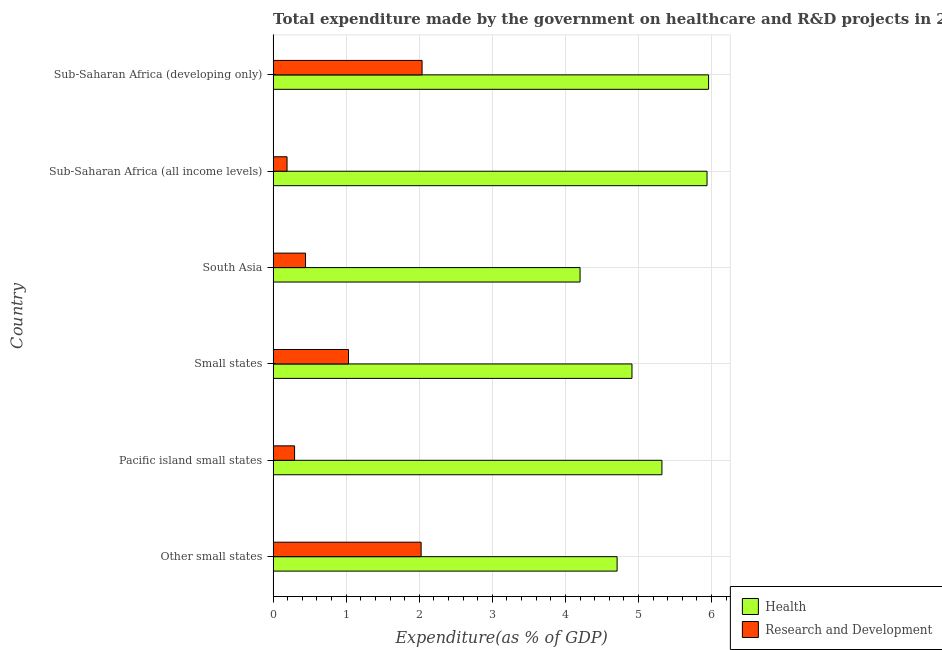How many groups of bars are there?
Provide a short and direct response. 6. Are the number of bars per tick equal to the number of legend labels?
Your answer should be very brief. Yes. Are the number of bars on each tick of the Y-axis equal?
Provide a short and direct response. Yes. What is the label of the 5th group of bars from the top?
Your response must be concise. Pacific island small states. In how many cases, is the number of bars for a given country not equal to the number of legend labels?
Provide a short and direct response. 0. What is the expenditure in healthcare in Sub-Saharan Africa (all income levels)?
Your answer should be very brief. 5.94. Across all countries, what is the maximum expenditure in healthcare?
Your response must be concise. 5.96. Across all countries, what is the minimum expenditure in healthcare?
Provide a short and direct response. 4.2. In which country was the expenditure in r&d maximum?
Your answer should be compact. Sub-Saharan Africa (developing only). In which country was the expenditure in r&d minimum?
Provide a short and direct response. Sub-Saharan Africa (all income levels). What is the total expenditure in healthcare in the graph?
Your response must be concise. 31.04. What is the difference between the expenditure in healthcare in Pacific island small states and that in Small states?
Your response must be concise. 0.41. What is the difference between the expenditure in r&d in Pacific island small states and the expenditure in healthcare in Small states?
Give a very brief answer. -4.62. What is the average expenditure in healthcare per country?
Keep it short and to the point. 5.17. What is the difference between the expenditure in r&d and expenditure in healthcare in Sub-Saharan Africa (developing only)?
Provide a short and direct response. -3.92. What is the ratio of the expenditure in healthcare in South Asia to that in Sub-Saharan Africa (all income levels)?
Your answer should be compact. 0.71. Is the difference between the expenditure in r&d in Pacific island small states and South Asia greater than the difference between the expenditure in healthcare in Pacific island small states and South Asia?
Give a very brief answer. No. What is the difference between the highest and the second highest expenditure in r&d?
Give a very brief answer. 0.01. What is the difference between the highest and the lowest expenditure in r&d?
Your answer should be very brief. 1.85. Is the sum of the expenditure in r&d in Pacific island small states and South Asia greater than the maximum expenditure in healthcare across all countries?
Provide a succinct answer. No. What does the 1st bar from the top in Other small states represents?
Offer a terse response. Research and Development. What does the 1st bar from the bottom in Pacific island small states represents?
Your answer should be compact. Health. How many bars are there?
Provide a short and direct response. 12. How many countries are there in the graph?
Your response must be concise. 6. Are the values on the major ticks of X-axis written in scientific E-notation?
Provide a short and direct response. No. What is the title of the graph?
Ensure brevity in your answer.  Total expenditure made by the government on healthcare and R&D projects in 2001. What is the label or title of the X-axis?
Offer a very short reply. Expenditure(as % of GDP). What is the label or title of the Y-axis?
Offer a very short reply. Country. What is the Expenditure(as % of GDP) in Health in Other small states?
Keep it short and to the point. 4.71. What is the Expenditure(as % of GDP) in Research and Development in Other small states?
Give a very brief answer. 2.03. What is the Expenditure(as % of GDP) in Health in Pacific island small states?
Ensure brevity in your answer.  5.32. What is the Expenditure(as % of GDP) in Research and Development in Pacific island small states?
Offer a very short reply. 0.29. What is the Expenditure(as % of GDP) in Health in Small states?
Offer a terse response. 4.91. What is the Expenditure(as % of GDP) in Research and Development in Small states?
Offer a very short reply. 1.03. What is the Expenditure(as % of GDP) of Health in South Asia?
Keep it short and to the point. 4.2. What is the Expenditure(as % of GDP) in Research and Development in South Asia?
Ensure brevity in your answer.  0.44. What is the Expenditure(as % of GDP) of Health in Sub-Saharan Africa (all income levels)?
Your answer should be compact. 5.94. What is the Expenditure(as % of GDP) in Research and Development in Sub-Saharan Africa (all income levels)?
Provide a succinct answer. 0.19. What is the Expenditure(as % of GDP) in Health in Sub-Saharan Africa (developing only)?
Your response must be concise. 5.96. What is the Expenditure(as % of GDP) of Research and Development in Sub-Saharan Africa (developing only)?
Your answer should be very brief. 2.04. Across all countries, what is the maximum Expenditure(as % of GDP) in Health?
Keep it short and to the point. 5.96. Across all countries, what is the maximum Expenditure(as % of GDP) of Research and Development?
Provide a short and direct response. 2.04. Across all countries, what is the minimum Expenditure(as % of GDP) in Health?
Your answer should be very brief. 4.2. Across all countries, what is the minimum Expenditure(as % of GDP) of Research and Development?
Offer a very short reply. 0.19. What is the total Expenditure(as % of GDP) in Health in the graph?
Your answer should be compact. 31.04. What is the total Expenditure(as % of GDP) of Research and Development in the graph?
Your answer should be compact. 6.02. What is the difference between the Expenditure(as % of GDP) of Health in Other small states and that in Pacific island small states?
Your answer should be very brief. -0.61. What is the difference between the Expenditure(as % of GDP) in Research and Development in Other small states and that in Pacific island small states?
Your answer should be compact. 1.73. What is the difference between the Expenditure(as % of GDP) of Health in Other small states and that in Small states?
Your answer should be very brief. -0.2. What is the difference between the Expenditure(as % of GDP) of Research and Development in Other small states and that in Small states?
Your answer should be very brief. 0.99. What is the difference between the Expenditure(as % of GDP) of Health in Other small states and that in South Asia?
Keep it short and to the point. 0.51. What is the difference between the Expenditure(as % of GDP) in Research and Development in Other small states and that in South Asia?
Keep it short and to the point. 1.58. What is the difference between the Expenditure(as % of GDP) of Health in Other small states and that in Sub-Saharan Africa (all income levels)?
Your response must be concise. -1.23. What is the difference between the Expenditure(as % of GDP) of Research and Development in Other small states and that in Sub-Saharan Africa (all income levels)?
Make the answer very short. 1.83. What is the difference between the Expenditure(as % of GDP) in Health in Other small states and that in Sub-Saharan Africa (developing only)?
Your answer should be very brief. -1.25. What is the difference between the Expenditure(as % of GDP) in Research and Development in Other small states and that in Sub-Saharan Africa (developing only)?
Offer a terse response. -0.01. What is the difference between the Expenditure(as % of GDP) of Health in Pacific island small states and that in Small states?
Your answer should be very brief. 0.41. What is the difference between the Expenditure(as % of GDP) of Research and Development in Pacific island small states and that in Small states?
Provide a succinct answer. -0.74. What is the difference between the Expenditure(as % of GDP) of Health in Pacific island small states and that in South Asia?
Offer a very short reply. 1.12. What is the difference between the Expenditure(as % of GDP) in Research and Development in Pacific island small states and that in South Asia?
Make the answer very short. -0.15. What is the difference between the Expenditure(as % of GDP) in Health in Pacific island small states and that in Sub-Saharan Africa (all income levels)?
Keep it short and to the point. -0.62. What is the difference between the Expenditure(as % of GDP) in Research and Development in Pacific island small states and that in Sub-Saharan Africa (all income levels)?
Offer a very short reply. 0.1. What is the difference between the Expenditure(as % of GDP) in Health in Pacific island small states and that in Sub-Saharan Africa (developing only)?
Make the answer very short. -0.64. What is the difference between the Expenditure(as % of GDP) of Research and Development in Pacific island small states and that in Sub-Saharan Africa (developing only)?
Your answer should be very brief. -1.74. What is the difference between the Expenditure(as % of GDP) of Health in Small states and that in South Asia?
Your answer should be compact. 0.71. What is the difference between the Expenditure(as % of GDP) of Research and Development in Small states and that in South Asia?
Offer a very short reply. 0.59. What is the difference between the Expenditure(as % of GDP) of Health in Small states and that in Sub-Saharan Africa (all income levels)?
Make the answer very short. -1.03. What is the difference between the Expenditure(as % of GDP) of Research and Development in Small states and that in Sub-Saharan Africa (all income levels)?
Your response must be concise. 0.84. What is the difference between the Expenditure(as % of GDP) of Health in Small states and that in Sub-Saharan Africa (developing only)?
Your answer should be compact. -1.05. What is the difference between the Expenditure(as % of GDP) in Research and Development in Small states and that in Sub-Saharan Africa (developing only)?
Make the answer very short. -1.01. What is the difference between the Expenditure(as % of GDP) of Health in South Asia and that in Sub-Saharan Africa (all income levels)?
Keep it short and to the point. -1.74. What is the difference between the Expenditure(as % of GDP) in Research and Development in South Asia and that in Sub-Saharan Africa (all income levels)?
Keep it short and to the point. 0.25. What is the difference between the Expenditure(as % of GDP) of Health in South Asia and that in Sub-Saharan Africa (developing only)?
Keep it short and to the point. -1.76. What is the difference between the Expenditure(as % of GDP) in Research and Development in South Asia and that in Sub-Saharan Africa (developing only)?
Your response must be concise. -1.6. What is the difference between the Expenditure(as % of GDP) of Health in Sub-Saharan Africa (all income levels) and that in Sub-Saharan Africa (developing only)?
Make the answer very short. -0.02. What is the difference between the Expenditure(as % of GDP) of Research and Development in Sub-Saharan Africa (all income levels) and that in Sub-Saharan Africa (developing only)?
Your response must be concise. -1.85. What is the difference between the Expenditure(as % of GDP) of Health in Other small states and the Expenditure(as % of GDP) of Research and Development in Pacific island small states?
Your answer should be compact. 4.41. What is the difference between the Expenditure(as % of GDP) in Health in Other small states and the Expenditure(as % of GDP) in Research and Development in Small states?
Provide a short and direct response. 3.68. What is the difference between the Expenditure(as % of GDP) of Health in Other small states and the Expenditure(as % of GDP) of Research and Development in South Asia?
Your response must be concise. 4.26. What is the difference between the Expenditure(as % of GDP) in Health in Other small states and the Expenditure(as % of GDP) in Research and Development in Sub-Saharan Africa (all income levels)?
Give a very brief answer. 4.52. What is the difference between the Expenditure(as % of GDP) of Health in Other small states and the Expenditure(as % of GDP) of Research and Development in Sub-Saharan Africa (developing only)?
Offer a terse response. 2.67. What is the difference between the Expenditure(as % of GDP) of Health in Pacific island small states and the Expenditure(as % of GDP) of Research and Development in Small states?
Give a very brief answer. 4.29. What is the difference between the Expenditure(as % of GDP) in Health in Pacific island small states and the Expenditure(as % of GDP) in Research and Development in South Asia?
Offer a terse response. 4.88. What is the difference between the Expenditure(as % of GDP) in Health in Pacific island small states and the Expenditure(as % of GDP) in Research and Development in Sub-Saharan Africa (all income levels)?
Your response must be concise. 5.13. What is the difference between the Expenditure(as % of GDP) in Health in Pacific island small states and the Expenditure(as % of GDP) in Research and Development in Sub-Saharan Africa (developing only)?
Your answer should be very brief. 3.28. What is the difference between the Expenditure(as % of GDP) of Health in Small states and the Expenditure(as % of GDP) of Research and Development in South Asia?
Your answer should be very brief. 4.47. What is the difference between the Expenditure(as % of GDP) of Health in Small states and the Expenditure(as % of GDP) of Research and Development in Sub-Saharan Africa (all income levels)?
Your answer should be very brief. 4.72. What is the difference between the Expenditure(as % of GDP) of Health in Small states and the Expenditure(as % of GDP) of Research and Development in Sub-Saharan Africa (developing only)?
Ensure brevity in your answer.  2.87. What is the difference between the Expenditure(as % of GDP) in Health in South Asia and the Expenditure(as % of GDP) in Research and Development in Sub-Saharan Africa (all income levels)?
Give a very brief answer. 4.01. What is the difference between the Expenditure(as % of GDP) of Health in South Asia and the Expenditure(as % of GDP) of Research and Development in Sub-Saharan Africa (developing only)?
Your answer should be compact. 2.16. What is the difference between the Expenditure(as % of GDP) in Health in Sub-Saharan Africa (all income levels) and the Expenditure(as % of GDP) in Research and Development in Sub-Saharan Africa (developing only)?
Your answer should be compact. 3.9. What is the average Expenditure(as % of GDP) in Health per country?
Give a very brief answer. 5.17. What is the average Expenditure(as % of GDP) in Research and Development per country?
Ensure brevity in your answer.  1. What is the difference between the Expenditure(as % of GDP) in Health and Expenditure(as % of GDP) in Research and Development in Other small states?
Provide a succinct answer. 2.68. What is the difference between the Expenditure(as % of GDP) of Health and Expenditure(as % of GDP) of Research and Development in Pacific island small states?
Keep it short and to the point. 5.03. What is the difference between the Expenditure(as % of GDP) in Health and Expenditure(as % of GDP) in Research and Development in Small states?
Offer a very short reply. 3.88. What is the difference between the Expenditure(as % of GDP) in Health and Expenditure(as % of GDP) in Research and Development in South Asia?
Your answer should be very brief. 3.76. What is the difference between the Expenditure(as % of GDP) in Health and Expenditure(as % of GDP) in Research and Development in Sub-Saharan Africa (all income levels)?
Ensure brevity in your answer.  5.75. What is the difference between the Expenditure(as % of GDP) of Health and Expenditure(as % of GDP) of Research and Development in Sub-Saharan Africa (developing only)?
Offer a very short reply. 3.92. What is the ratio of the Expenditure(as % of GDP) of Health in Other small states to that in Pacific island small states?
Your answer should be compact. 0.88. What is the ratio of the Expenditure(as % of GDP) of Research and Development in Other small states to that in Pacific island small states?
Your answer should be very brief. 6.9. What is the ratio of the Expenditure(as % of GDP) of Health in Other small states to that in Small states?
Ensure brevity in your answer.  0.96. What is the ratio of the Expenditure(as % of GDP) in Research and Development in Other small states to that in Small states?
Ensure brevity in your answer.  1.96. What is the ratio of the Expenditure(as % of GDP) of Health in Other small states to that in South Asia?
Provide a short and direct response. 1.12. What is the ratio of the Expenditure(as % of GDP) in Research and Development in Other small states to that in South Asia?
Provide a short and direct response. 4.57. What is the ratio of the Expenditure(as % of GDP) in Health in Other small states to that in Sub-Saharan Africa (all income levels)?
Keep it short and to the point. 0.79. What is the ratio of the Expenditure(as % of GDP) of Research and Development in Other small states to that in Sub-Saharan Africa (all income levels)?
Provide a succinct answer. 10.63. What is the ratio of the Expenditure(as % of GDP) in Health in Other small states to that in Sub-Saharan Africa (developing only)?
Offer a very short reply. 0.79. What is the ratio of the Expenditure(as % of GDP) in Research and Development in Other small states to that in Sub-Saharan Africa (developing only)?
Provide a short and direct response. 0.99. What is the ratio of the Expenditure(as % of GDP) in Health in Pacific island small states to that in Small states?
Make the answer very short. 1.08. What is the ratio of the Expenditure(as % of GDP) of Research and Development in Pacific island small states to that in Small states?
Give a very brief answer. 0.28. What is the ratio of the Expenditure(as % of GDP) in Health in Pacific island small states to that in South Asia?
Give a very brief answer. 1.27. What is the ratio of the Expenditure(as % of GDP) in Research and Development in Pacific island small states to that in South Asia?
Ensure brevity in your answer.  0.66. What is the ratio of the Expenditure(as % of GDP) in Health in Pacific island small states to that in Sub-Saharan Africa (all income levels)?
Provide a short and direct response. 0.9. What is the ratio of the Expenditure(as % of GDP) of Research and Development in Pacific island small states to that in Sub-Saharan Africa (all income levels)?
Give a very brief answer. 1.54. What is the ratio of the Expenditure(as % of GDP) of Health in Pacific island small states to that in Sub-Saharan Africa (developing only)?
Ensure brevity in your answer.  0.89. What is the ratio of the Expenditure(as % of GDP) in Research and Development in Pacific island small states to that in Sub-Saharan Africa (developing only)?
Ensure brevity in your answer.  0.14. What is the ratio of the Expenditure(as % of GDP) in Health in Small states to that in South Asia?
Make the answer very short. 1.17. What is the ratio of the Expenditure(as % of GDP) of Research and Development in Small states to that in South Asia?
Your response must be concise. 2.33. What is the ratio of the Expenditure(as % of GDP) in Health in Small states to that in Sub-Saharan Africa (all income levels)?
Offer a very short reply. 0.83. What is the ratio of the Expenditure(as % of GDP) in Research and Development in Small states to that in Sub-Saharan Africa (all income levels)?
Your answer should be very brief. 5.41. What is the ratio of the Expenditure(as % of GDP) of Health in Small states to that in Sub-Saharan Africa (developing only)?
Provide a short and direct response. 0.82. What is the ratio of the Expenditure(as % of GDP) in Research and Development in Small states to that in Sub-Saharan Africa (developing only)?
Your response must be concise. 0.51. What is the ratio of the Expenditure(as % of GDP) of Health in South Asia to that in Sub-Saharan Africa (all income levels)?
Provide a succinct answer. 0.71. What is the ratio of the Expenditure(as % of GDP) of Research and Development in South Asia to that in Sub-Saharan Africa (all income levels)?
Your response must be concise. 2.33. What is the ratio of the Expenditure(as % of GDP) of Health in South Asia to that in Sub-Saharan Africa (developing only)?
Your answer should be very brief. 0.7. What is the ratio of the Expenditure(as % of GDP) in Research and Development in South Asia to that in Sub-Saharan Africa (developing only)?
Offer a terse response. 0.22. What is the ratio of the Expenditure(as % of GDP) in Research and Development in Sub-Saharan Africa (all income levels) to that in Sub-Saharan Africa (developing only)?
Provide a succinct answer. 0.09. What is the difference between the highest and the second highest Expenditure(as % of GDP) in Health?
Offer a very short reply. 0.02. What is the difference between the highest and the second highest Expenditure(as % of GDP) in Research and Development?
Provide a short and direct response. 0.01. What is the difference between the highest and the lowest Expenditure(as % of GDP) in Health?
Give a very brief answer. 1.76. What is the difference between the highest and the lowest Expenditure(as % of GDP) in Research and Development?
Provide a succinct answer. 1.85. 